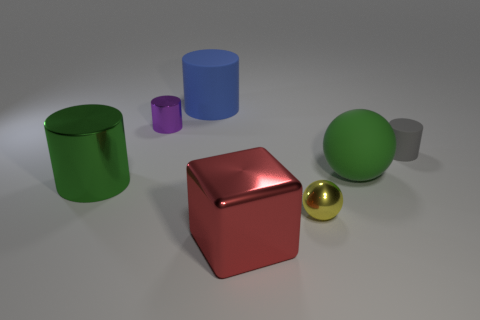What is the color of the tiny rubber cylinder?
Provide a succinct answer. Gray. There is a object that is both in front of the green matte ball and to the right of the large red thing; what color is it?
Keep it short and to the point. Yellow. What is the color of the big cylinder behind the matte cylinder that is in front of the big blue cylinder that is behind the gray cylinder?
Provide a short and direct response. Blue. There is a metallic cube that is the same size as the green ball; what color is it?
Your answer should be compact. Red. The large green matte thing that is behind the big red block in front of the big green thing in front of the large green matte sphere is what shape?
Offer a very short reply. Sphere. There is a matte object that is the same color as the large metallic cylinder; what shape is it?
Give a very brief answer. Sphere. What number of things are either purple things or large objects on the right side of the big blue matte cylinder?
Your response must be concise. 3. There is a shiny cylinder that is in front of the green ball; does it have the same size as the yellow metal ball?
Your response must be concise. No. What is the tiny object that is to the right of the tiny yellow thing made of?
Keep it short and to the point. Rubber. Are there an equal number of big matte things to the right of the shiny block and big green metallic things that are right of the small gray object?
Offer a very short reply. No. 